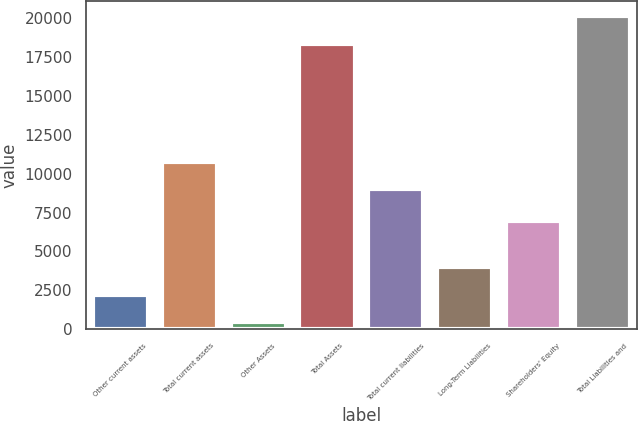Convert chart to OTSL. <chart><loc_0><loc_0><loc_500><loc_500><bar_chart><fcel>Other current assets<fcel>Total current assets<fcel>Other Assets<fcel>Total Assets<fcel>Total current liabilities<fcel>Long-Term Liabilities<fcel>Shareholders' Equity<fcel>Total Liabilities and<nl><fcel>2237<fcel>10763<fcel>452<fcel>18302<fcel>8978<fcel>4022<fcel>6964<fcel>20087<nl></chart> 